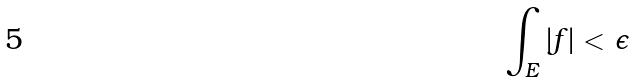<formula> <loc_0><loc_0><loc_500><loc_500>\int _ { E } | f | < \epsilon</formula> 